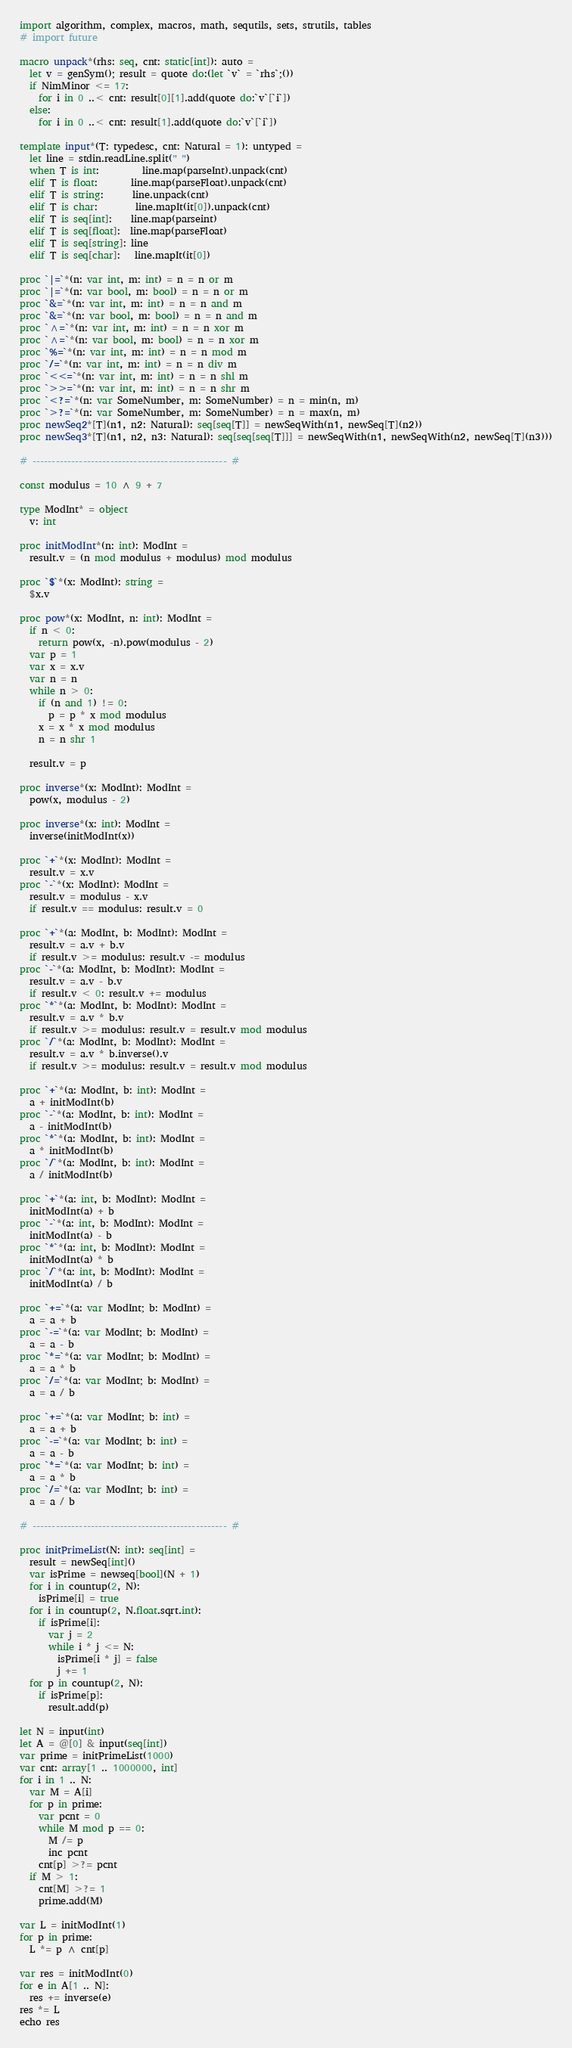Convert code to text. <code><loc_0><loc_0><loc_500><loc_500><_Nim_>import algorithm, complex, macros, math, sequtils, sets, strutils, tables
# import future

macro unpack*(rhs: seq, cnt: static[int]): auto =
  let v = genSym(); result = quote do:(let `v` = `rhs`;())
  if NimMinor <= 17:
    for i in 0 ..< cnt: result[0][1].add(quote do:`v`[`i`])
  else:
    for i in 0 ..< cnt: result[1].add(quote do:`v`[`i`])

template input*(T: typedesc, cnt: Natural = 1): untyped =
  let line = stdin.readLine.split(" ")
  when T is int:         line.map(parseInt).unpack(cnt)
  elif T is float:       line.map(parseFloat).unpack(cnt)
  elif T is string:      line.unpack(cnt)
  elif T is char:        line.mapIt(it[0]).unpack(cnt)
  elif T is seq[int]:    line.map(parseint)
  elif T is seq[float]:  line.map(parseFloat)
  elif T is seq[string]: line
  elif T is seq[char]:   line.mapIt(it[0])

proc `|=`*(n: var int, m: int) = n = n or m
proc `|=`*(n: var bool, m: bool) = n = n or m
proc `&=`*(n: var int, m: int) = n = n and m
proc `&=`*(n: var bool, m: bool) = n = n and m
proc `^=`*(n: var int, m: int) = n = n xor m
proc `^=`*(n: var bool, m: bool) = n = n xor m
proc `%=`*(n: var int, m: int) = n = n mod m
proc `/=`*(n: var int, m: int) = n = n div m
proc `<<=`*(n: var int, m: int) = n = n shl m
proc `>>=`*(n: var int, m: int) = n = n shr m
proc `<?=`*(n: var SomeNumber, m: SomeNumber) = n = min(n, m)
proc `>?=`*(n: var SomeNumber, m: SomeNumber) = n = max(n, m)
proc newSeq2*[T](n1, n2: Natural): seq[seq[T]] = newSeqWith(n1, newSeq[T](n2))
proc newSeq3*[T](n1, n2, n3: Natural): seq[seq[seq[T]]] = newSeqWith(n1, newSeqWith(n2, newSeq[T](n3)))

# -------------------------------------------------- #

const modulus = 10 ^ 9 + 7

type ModInt* = object
  v: int

proc initModInt*(n: int): ModInt =
  result.v = (n mod modulus + modulus) mod modulus

proc `$`*(x: ModInt): string =
  $x.v

proc pow*(x: ModInt, n: int): ModInt =
  if n < 0:
    return pow(x, -n).pow(modulus - 2)
  var p = 1
  var x = x.v
  var n = n
  while n > 0:
    if (n and 1) != 0:
      p = p * x mod modulus
    x = x * x mod modulus
    n = n shr 1

  result.v = p

proc inverse*(x: ModInt): ModInt =
  pow(x, modulus - 2)

proc inverse*(x: int): ModInt =
  inverse(initModInt(x))

proc `+`*(x: ModInt): ModInt =
  result.v = x.v
proc `-`*(x: ModInt): ModInt =
  result.v = modulus - x.v
  if result.v == modulus: result.v = 0

proc `+`*(a: ModInt, b: ModInt): ModInt =
  result.v = a.v + b.v
  if result.v >= modulus: result.v -= modulus
proc `-`*(a: ModInt, b: ModInt): ModInt =
  result.v = a.v - b.v
  if result.v < 0: result.v += modulus
proc `*`*(a: ModInt, b: ModInt): ModInt =
  result.v = a.v * b.v
  if result.v >= modulus: result.v = result.v mod modulus
proc `/`*(a: ModInt, b: ModInt): ModInt =
  result.v = a.v * b.inverse().v
  if result.v >= modulus: result.v = result.v mod modulus

proc `+`*(a: ModInt, b: int): ModInt =
  a + initModInt(b)
proc `-`*(a: ModInt, b: int): ModInt =
  a - initModInt(b)
proc `*`*(a: ModInt, b: int): ModInt =
  a * initModInt(b)
proc `/`*(a: ModInt, b: int): ModInt =
  a / initModInt(b)

proc `+`*(a: int, b: ModInt): ModInt =
  initModInt(a) + b
proc `-`*(a: int, b: ModInt): ModInt =
  initModInt(a) - b
proc `*`*(a: int, b: ModInt): ModInt =
  initModInt(a) * b
proc `/`*(a: int, b: ModInt): ModInt =
  initModInt(a) / b

proc `+=`*(a: var ModInt; b: ModInt) =
  a = a + b
proc `-=`*(a: var ModInt; b: ModInt) =
  a = a - b
proc `*=`*(a: var ModInt; b: ModInt) =
  a = a * b
proc `/=`*(a: var ModInt; b: ModInt) =
  a = a / b

proc `+=`*(a: var ModInt; b: int) =
  a = a + b
proc `-=`*(a: var ModInt; b: int) =
  a = a - b
proc `*=`*(a: var ModInt; b: int) =
  a = a * b
proc `/=`*(a: var ModInt; b: int) =
  a = a / b

# -------------------------------------------------- #

proc initPrimeList(N: int): seq[int] =
  result = newSeq[int]()
  var isPrime = newseq[bool](N + 1)
  for i in countup(2, N):
    isPrime[i] = true
  for i in countup(2, N.float.sqrt.int):
    if isPrime[i]:
      var j = 2
      while i * j <= N:
        isPrime[i * j] = false
        j += 1
  for p in countup(2, N):
    if isPrime[p]:
      result.add(p)

let N = input(int)
let A = @[0] & input(seq[int])
var prime = initPrimeList(1000)
var cnt: array[1 .. 1000000, int]
for i in 1 .. N:
  var M = A[i]
  for p in prime:
    var pcnt = 0
    while M mod p == 0:
      M /= p
      inc pcnt
    cnt[p] >?= pcnt
  if M > 1:
    cnt[M] >?= 1
    prime.add(M)

var L = initModInt(1)
for p in prime:
  L *= p ^ cnt[p]

var res = initModInt(0)
for e in A[1 .. N]:
  res += inverse(e)
res *= L
echo res</code> 